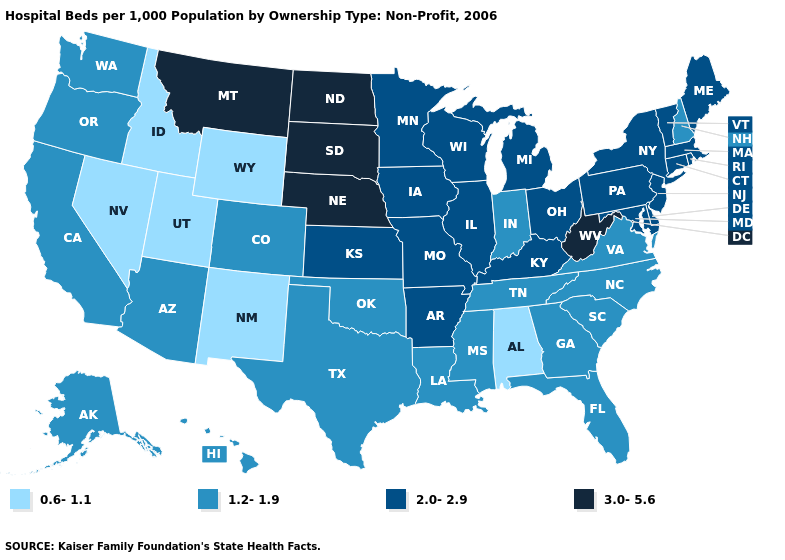Does the first symbol in the legend represent the smallest category?
Write a very short answer. Yes. What is the highest value in states that border North Carolina?
Keep it brief. 1.2-1.9. Name the states that have a value in the range 1.2-1.9?
Quick response, please. Alaska, Arizona, California, Colorado, Florida, Georgia, Hawaii, Indiana, Louisiana, Mississippi, New Hampshire, North Carolina, Oklahoma, Oregon, South Carolina, Tennessee, Texas, Virginia, Washington. What is the value of Connecticut?
Quick response, please. 2.0-2.9. What is the value of Florida?
Concise answer only. 1.2-1.9. Name the states that have a value in the range 0.6-1.1?
Keep it brief. Alabama, Idaho, Nevada, New Mexico, Utah, Wyoming. Does North Carolina have the same value as Alaska?
Keep it brief. Yes. What is the value of Alabama?
Keep it brief. 0.6-1.1. Does Florida have the highest value in the USA?
Keep it brief. No. What is the highest value in states that border Virginia?
Short answer required. 3.0-5.6. Name the states that have a value in the range 2.0-2.9?
Be succinct. Arkansas, Connecticut, Delaware, Illinois, Iowa, Kansas, Kentucky, Maine, Maryland, Massachusetts, Michigan, Minnesota, Missouri, New Jersey, New York, Ohio, Pennsylvania, Rhode Island, Vermont, Wisconsin. Does Kentucky have a lower value than West Virginia?
Keep it brief. Yes. Name the states that have a value in the range 1.2-1.9?
Write a very short answer. Alaska, Arizona, California, Colorado, Florida, Georgia, Hawaii, Indiana, Louisiana, Mississippi, New Hampshire, North Carolina, Oklahoma, Oregon, South Carolina, Tennessee, Texas, Virginia, Washington. Which states have the lowest value in the South?
Give a very brief answer. Alabama. Among the states that border Arkansas , which have the highest value?
Concise answer only. Missouri. 